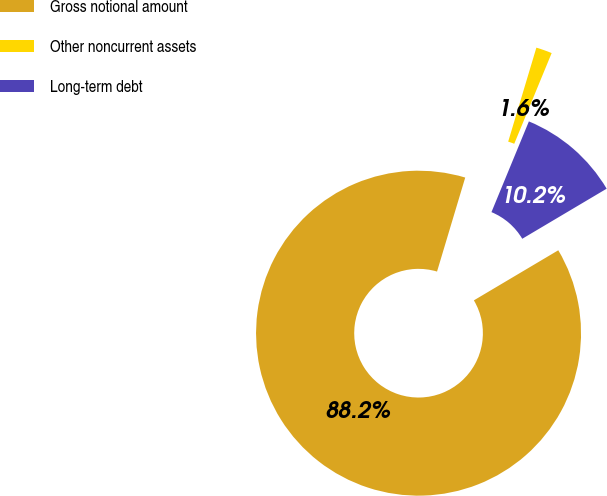Convert chart to OTSL. <chart><loc_0><loc_0><loc_500><loc_500><pie_chart><fcel>Gross notional amount<fcel>Other noncurrent assets<fcel>Long-term debt<nl><fcel>88.17%<fcel>1.59%<fcel>10.25%<nl></chart> 